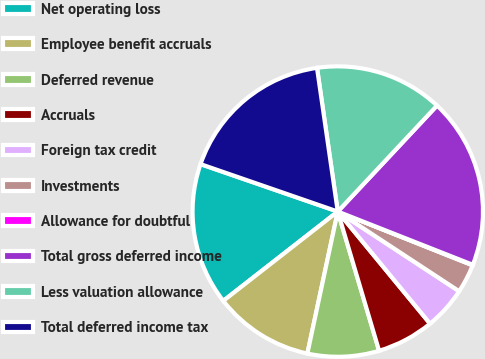Convert chart. <chart><loc_0><loc_0><loc_500><loc_500><pie_chart><fcel>Net operating loss<fcel>Employee benefit accruals<fcel>Deferred revenue<fcel>Accruals<fcel>Foreign tax credit<fcel>Investments<fcel>Allowance for doubtful<fcel>Total gross deferred income<fcel>Less valuation allowance<fcel>Total deferred income tax<nl><fcel>15.84%<fcel>11.1%<fcel>7.95%<fcel>6.37%<fcel>4.79%<fcel>3.21%<fcel>0.06%<fcel>19.0%<fcel>14.26%<fcel>17.42%<nl></chart> 